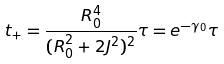Convert formula to latex. <formula><loc_0><loc_0><loc_500><loc_500>t _ { + } = \frac { R _ { 0 } ^ { 4 } } { ( R _ { 0 } ^ { 2 } + 2 J ^ { 2 } ) ^ { 2 } } \tau = e ^ { - \gamma _ { 0 } } \tau</formula> 